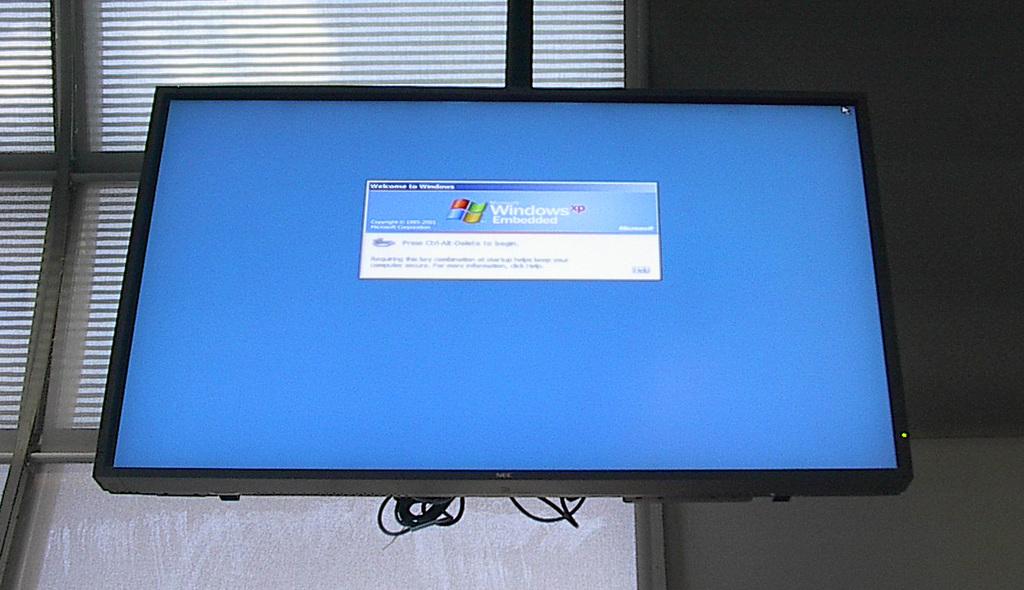What type of computer is that?
Offer a very short reply. Windows. What version of windows is installed on the computer?
Your answer should be compact. Xp. 